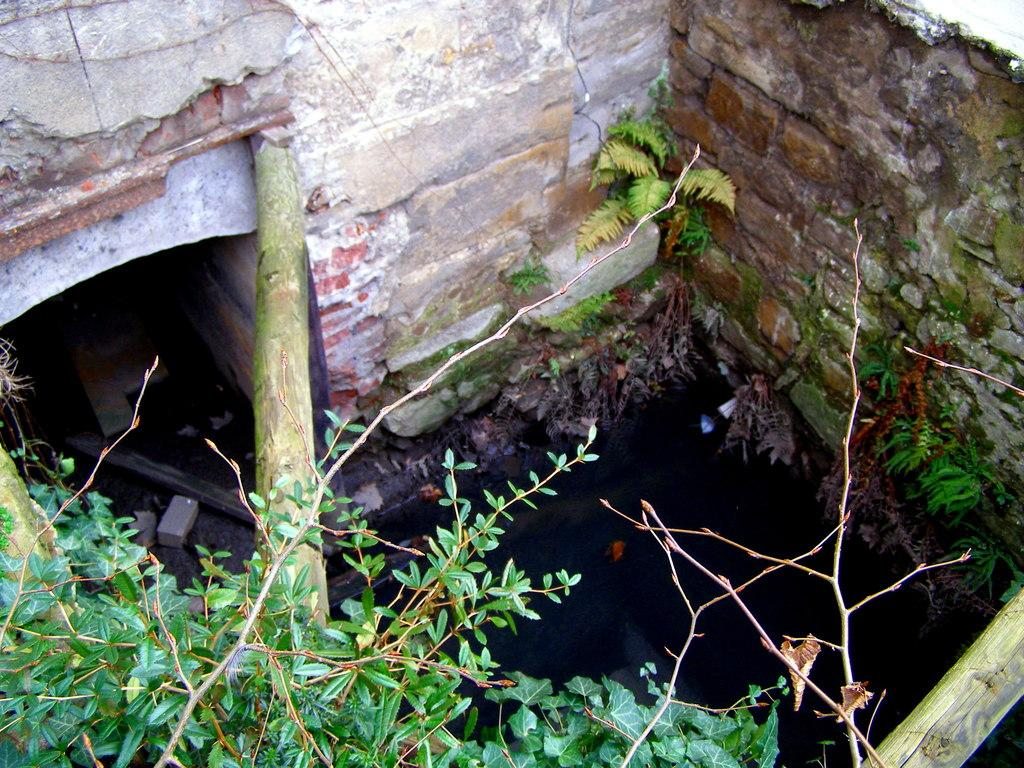What is located in the middle of the image? There is a drainage in the middle of the image. What can be seen at the bottom of the image? There are plants at the bottom of the image. What type of honey can be seen dripping from the drainage in the image? There is no honey present in the image; it features a drainage and plants. What appliance is visible near the drainage in the image? There is no appliance visible in the image; it only features a drainage and plants. 